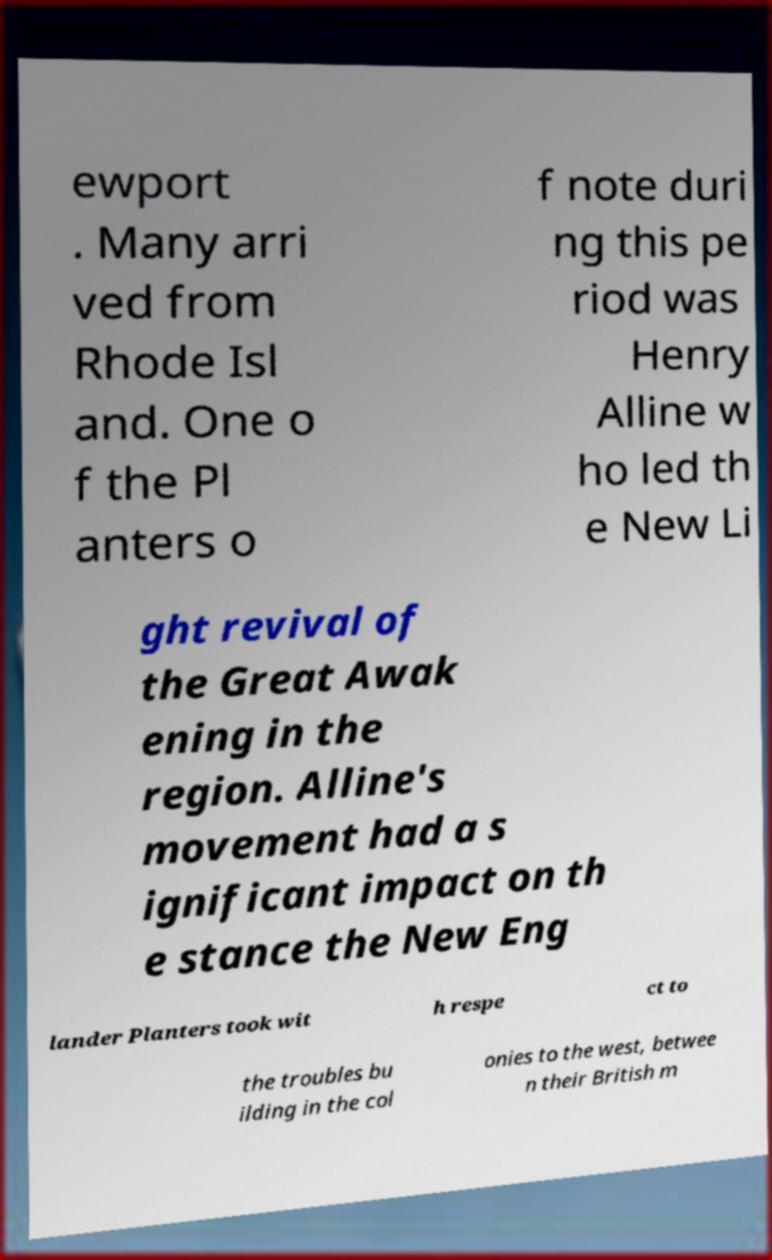Please read and relay the text visible in this image. What does it say? ewport . Many arri ved from Rhode Isl and. One o f the Pl anters o f note duri ng this pe riod was Henry Alline w ho led th e New Li ght revival of the Great Awak ening in the region. Alline's movement had a s ignificant impact on th e stance the New Eng lander Planters took wit h respe ct to the troubles bu ilding in the col onies to the west, betwee n their British m 